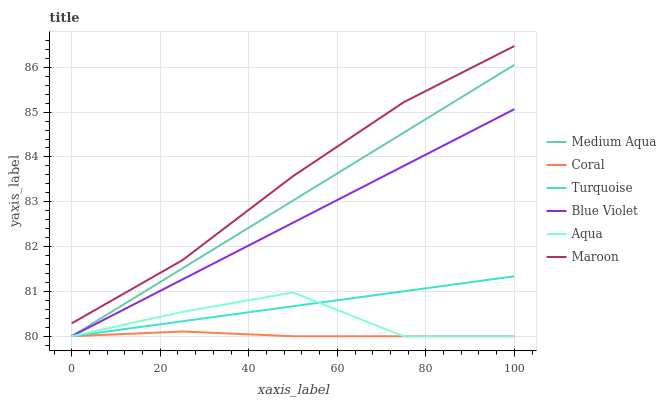Does Coral have the minimum area under the curve?
Answer yes or no. Yes. Does Maroon have the maximum area under the curve?
Answer yes or no. Yes. Does Aqua have the minimum area under the curve?
Answer yes or no. No. Does Aqua have the maximum area under the curve?
Answer yes or no. No. Is Turquoise the smoothest?
Answer yes or no. Yes. Is Aqua the roughest?
Answer yes or no. Yes. Is Coral the smoothest?
Answer yes or no. No. Is Coral the roughest?
Answer yes or no. No. Does Maroon have the lowest value?
Answer yes or no. No. Does Maroon have the highest value?
Answer yes or no. Yes. Does Aqua have the highest value?
Answer yes or no. No. Is Aqua less than Maroon?
Answer yes or no. Yes. Is Maroon greater than Turquoise?
Answer yes or no. Yes. Does Medium Aqua intersect Turquoise?
Answer yes or no. Yes. Is Medium Aqua less than Turquoise?
Answer yes or no. No. Is Medium Aqua greater than Turquoise?
Answer yes or no. No. Does Aqua intersect Maroon?
Answer yes or no. No. 